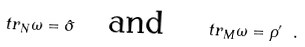<formula> <loc_0><loc_0><loc_500><loc_500>\ t r _ { N } \omega = \hat { \sigma } \quad \text {and} \quad \ t r _ { M } \omega = \rho ^ { \prime } \ .</formula> 